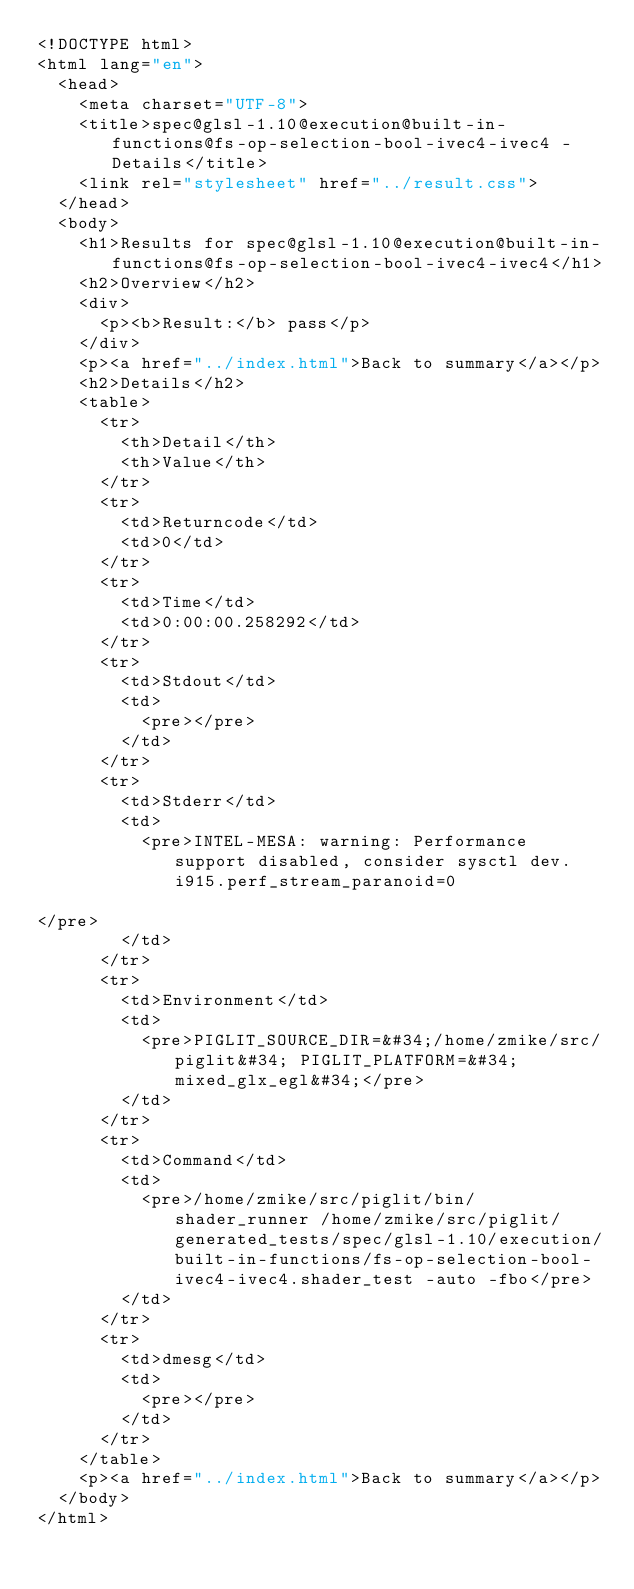<code> <loc_0><loc_0><loc_500><loc_500><_HTML_><!DOCTYPE html>
<html lang="en">
  <head>
    <meta charset="UTF-8">
    <title>spec@glsl-1.10@execution@built-in-functions@fs-op-selection-bool-ivec4-ivec4 - Details</title>
    <link rel="stylesheet" href="../result.css">
  </head>
  <body>
    <h1>Results for spec@glsl-1.10@execution@built-in-functions@fs-op-selection-bool-ivec4-ivec4</h1>
    <h2>Overview</h2>
    <div>
      <p><b>Result:</b> pass</p>
    </div>
    <p><a href="../index.html">Back to summary</a></p>
    <h2>Details</h2>
    <table>
      <tr>
        <th>Detail</th>
        <th>Value</th>
      </tr>
      <tr>
        <td>Returncode</td>
        <td>0</td>
      </tr>
      <tr>
        <td>Time</td>
        <td>0:00:00.258292</td>
      </tr>
      <tr>
        <td>Stdout</td>
        <td>
          <pre></pre>
        </td>
      </tr>
      <tr>
        <td>Stderr</td>
        <td>
          <pre>INTEL-MESA: warning: Performance support disabled, consider sysctl dev.i915.perf_stream_paranoid=0

</pre>
        </td>
      </tr>
      <tr>
        <td>Environment</td>
        <td>
          <pre>PIGLIT_SOURCE_DIR=&#34;/home/zmike/src/piglit&#34; PIGLIT_PLATFORM=&#34;mixed_glx_egl&#34;</pre>
        </td>
      </tr>
      <tr>
        <td>Command</td>
        <td>
          <pre>/home/zmike/src/piglit/bin/shader_runner /home/zmike/src/piglit/generated_tests/spec/glsl-1.10/execution/built-in-functions/fs-op-selection-bool-ivec4-ivec4.shader_test -auto -fbo</pre>
        </td>
      </tr>
      <tr>
        <td>dmesg</td>
        <td>
          <pre></pre>
        </td>
      </tr>
    </table>
    <p><a href="../index.html">Back to summary</a></p>
  </body>
</html>
</code> 